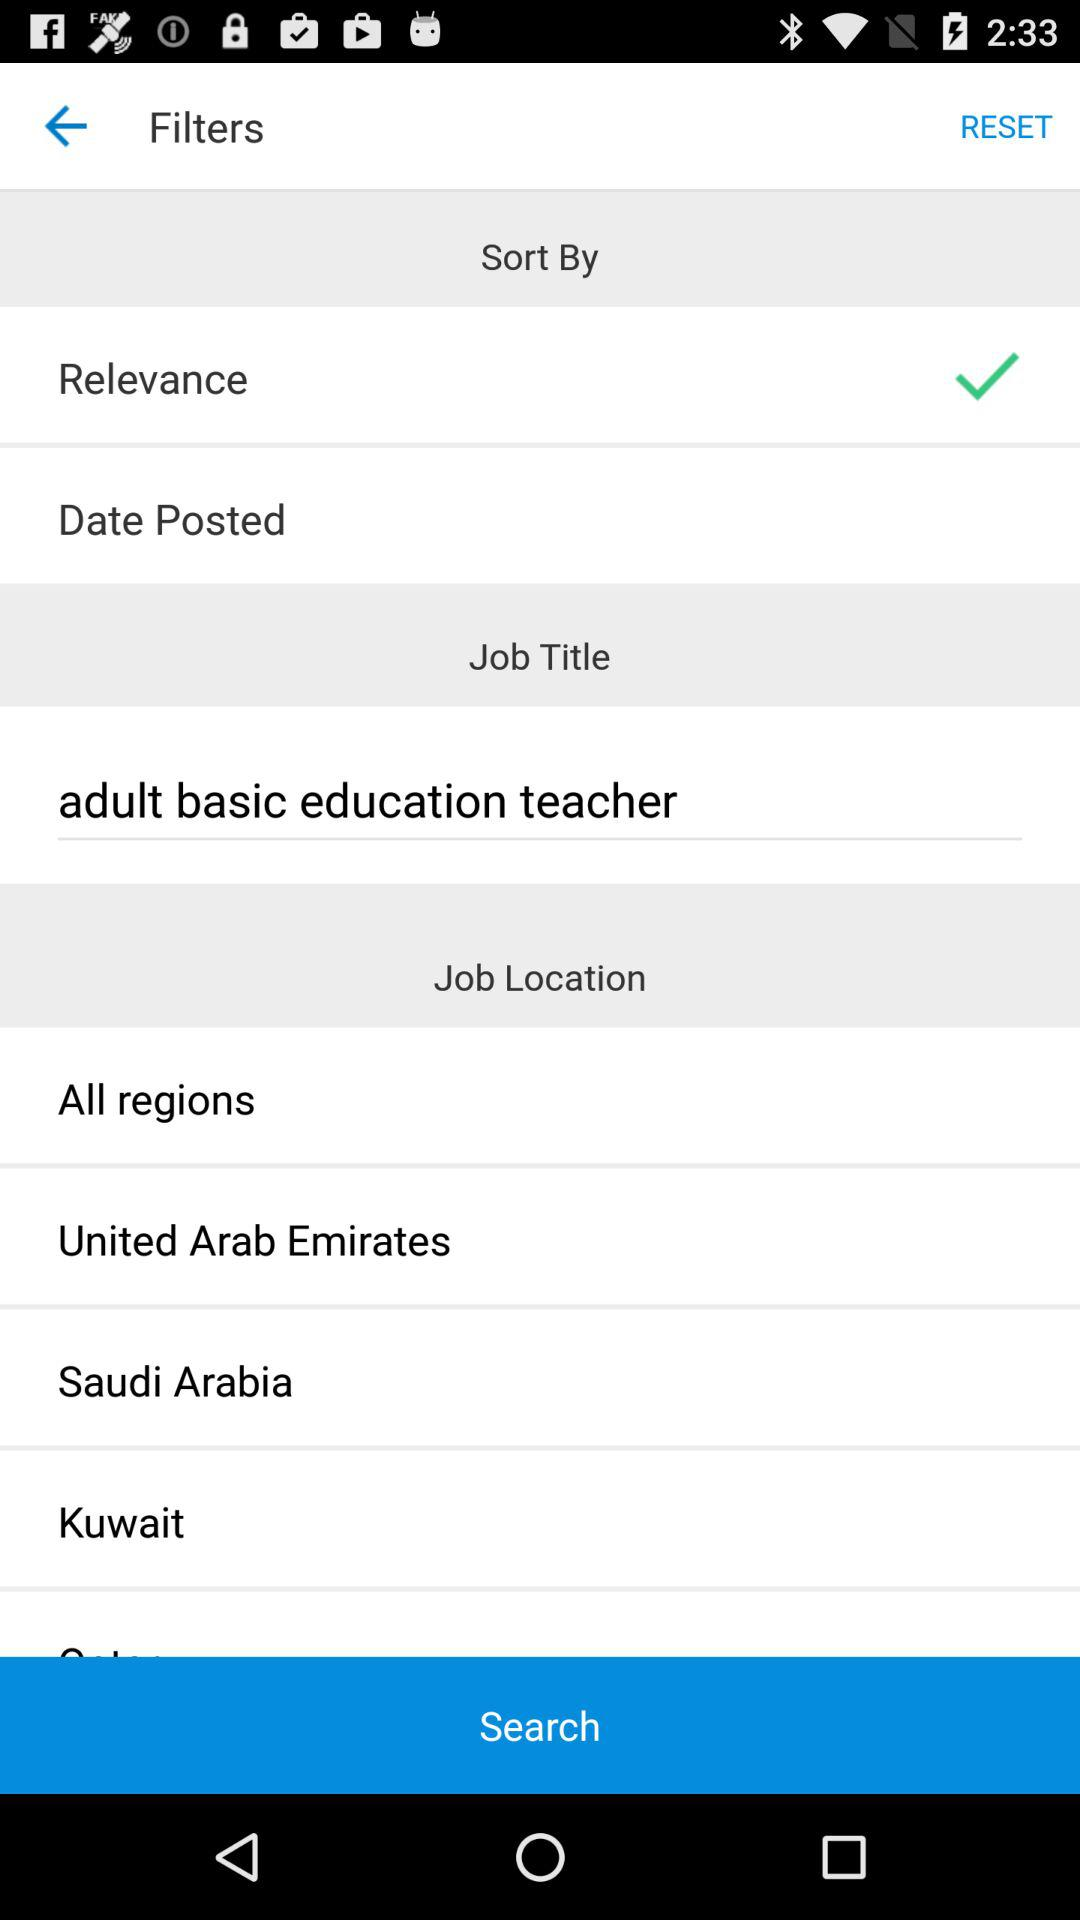What is the job title? The job title is "adult basic education teacher". 